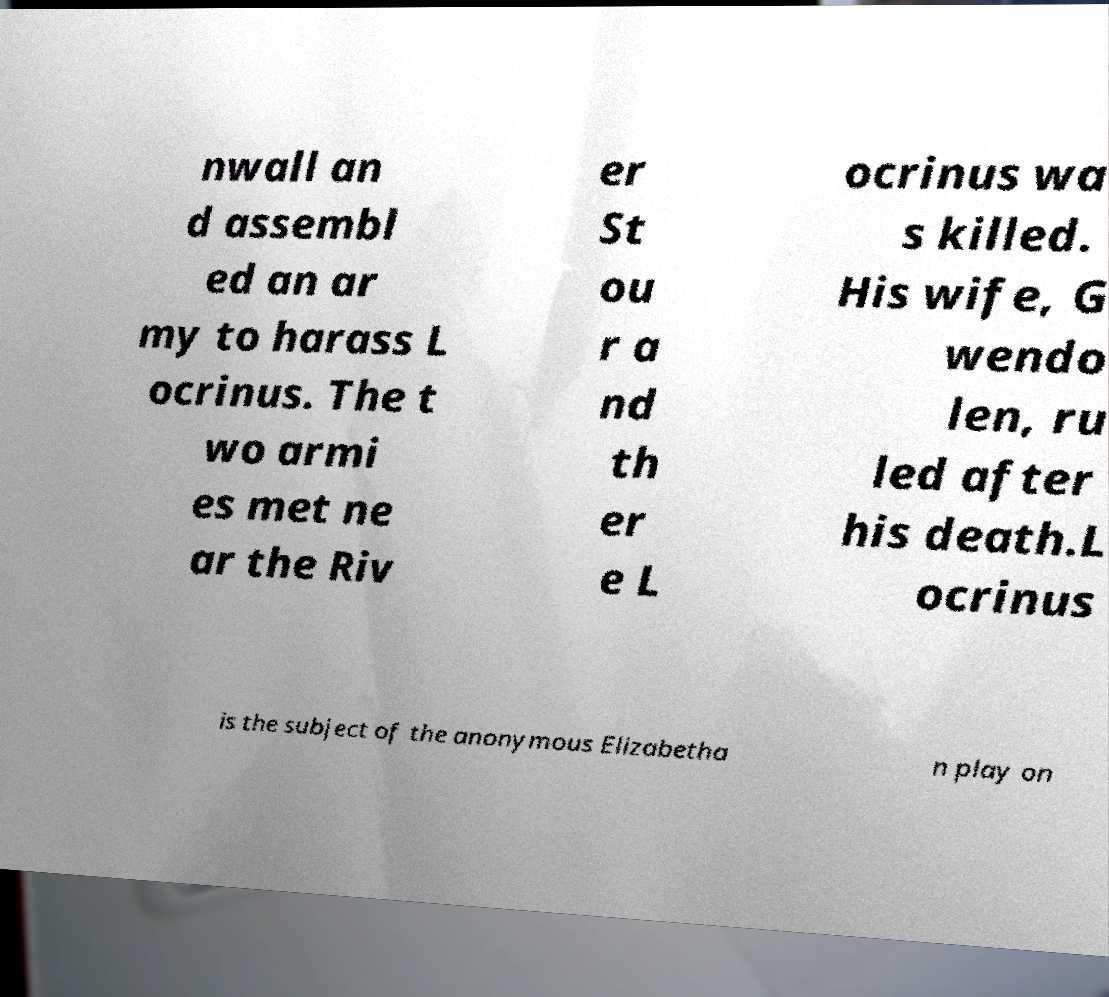What messages or text are displayed in this image? I need them in a readable, typed format. nwall an d assembl ed an ar my to harass L ocrinus. The t wo armi es met ne ar the Riv er St ou r a nd th er e L ocrinus wa s killed. His wife, G wendo len, ru led after his death.L ocrinus is the subject of the anonymous Elizabetha n play on 